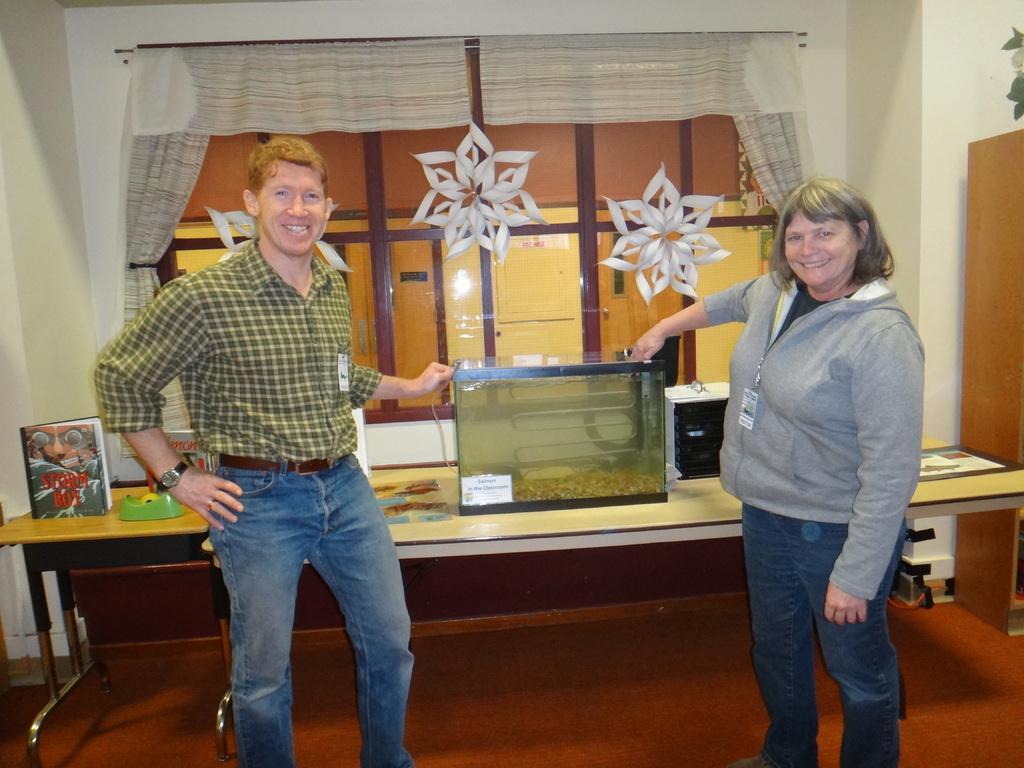Can you describe this image briefly? Here is the men and women standing and holding some glass object. This is the table with a book,a green color object and glass object. In this object I can see a water and some metal thing inside it. These are the white paper flowers attached to the window. These are the curtains. 